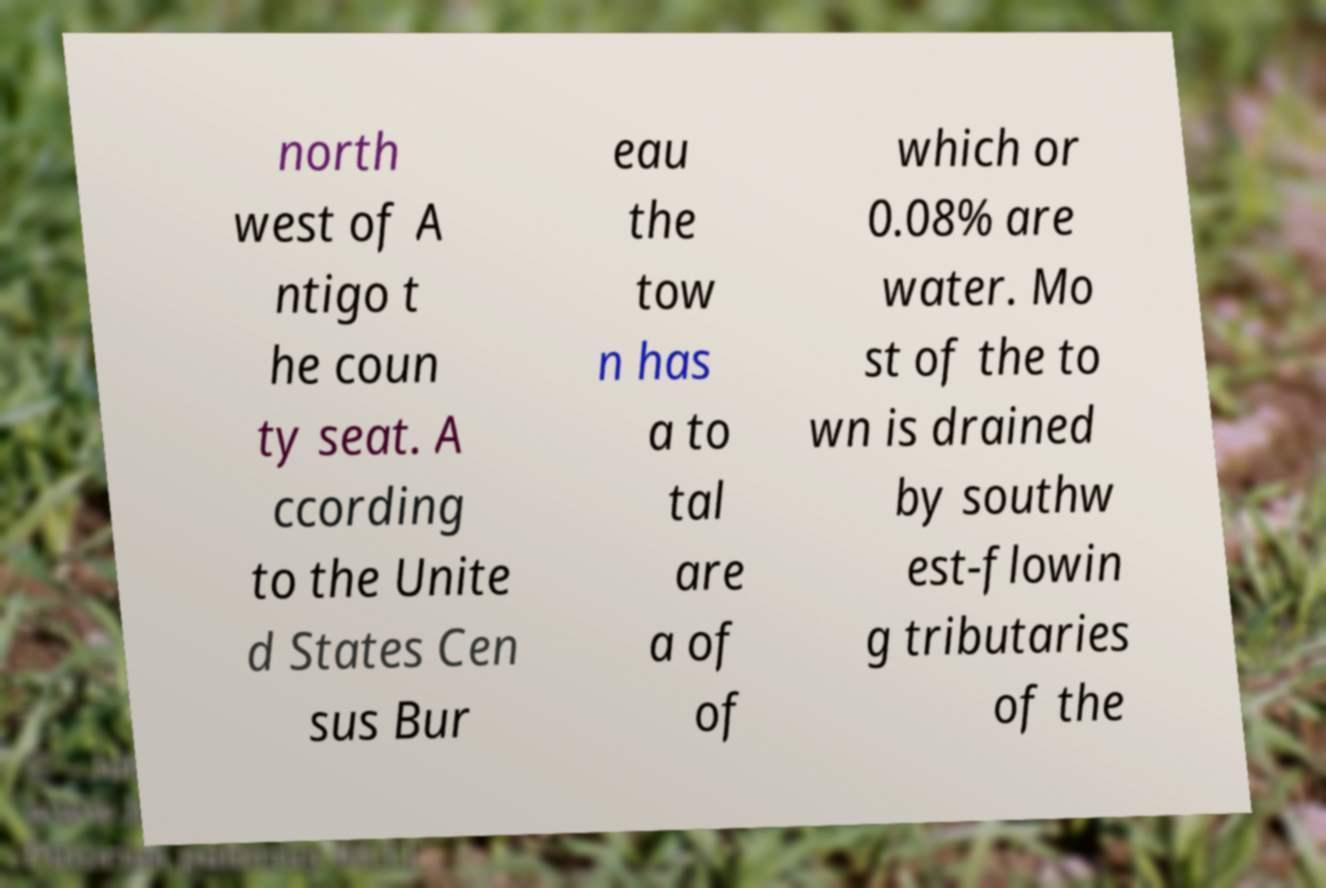Can you read and provide the text displayed in the image?This photo seems to have some interesting text. Can you extract and type it out for me? north west of A ntigo t he coun ty seat. A ccording to the Unite d States Cen sus Bur eau the tow n has a to tal are a of of which or 0.08% are water. Mo st of the to wn is drained by southw est-flowin g tributaries of the 